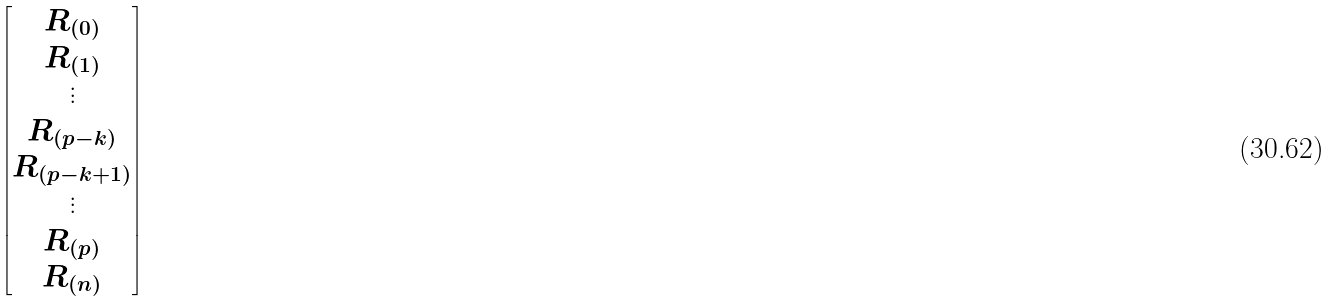<formula> <loc_0><loc_0><loc_500><loc_500>\begin{bmatrix} R _ { ( 0 ) } \\ R _ { ( 1 ) } \\ \vdots \\ R _ { ( p - k ) } \\ R _ { ( p - k + 1 ) } \\ \vdots \\ R _ { ( p ) } \\ R _ { ( n ) } \end{bmatrix}</formula> 